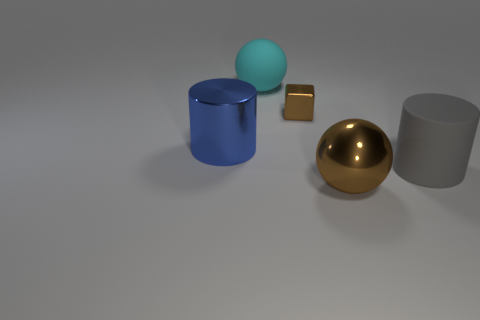How many other things are the same size as the metal block?
Make the answer very short. 0. The object that is the same color as the small cube is what size?
Provide a succinct answer. Large. The big cylinder to the left of the big ball that is in front of the metallic cylinder is made of what material?
Keep it short and to the point. Metal. There is a small brown metallic cube; are there any cyan rubber things on the right side of it?
Provide a short and direct response. No. Are there more balls behind the big blue cylinder than yellow shiny objects?
Provide a succinct answer. Yes. Are there any metallic objects of the same color as the small metal block?
Your response must be concise. Yes. There is a metal ball that is the same size as the cyan matte object; what color is it?
Your response must be concise. Brown. There is a big matte object that is left of the large gray cylinder; is there a matte object that is in front of it?
Your response must be concise. Yes. What is the material of the large ball that is behind the big gray cylinder?
Make the answer very short. Rubber. Are the big cylinder that is on the left side of the big brown sphere and the large ball that is in front of the blue shiny thing made of the same material?
Keep it short and to the point. Yes. 